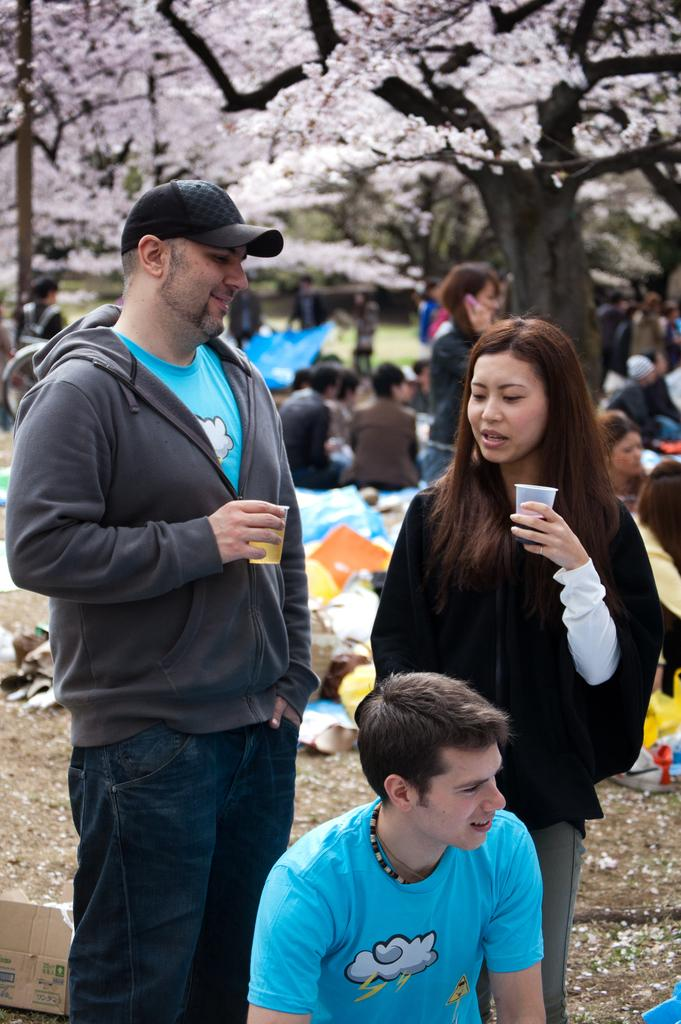What is the main activity of the people in the image? There is a group of people on the ground. What are two people holding in their hands? Two people are holding glasses with their hands. What object can be seen in the image besides the people and glasses? There is a box in the image. What can be seen in the background of the image? There are trees visible in the background. How many objects can be identified in the image? There are some objects in the image, but the exact number is not specified. What type of hat is the person wearing in the image? There is no person wearing a hat in the image. What form does the bath take in the image? There is no bath present in the image. 